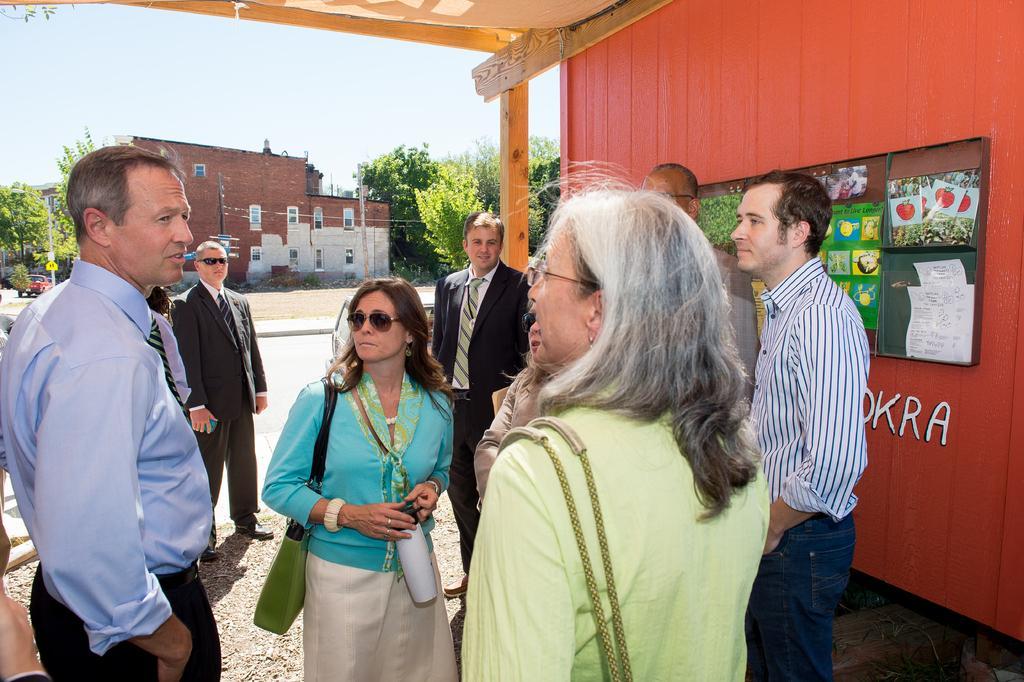In one or two sentences, can you explain what this image depicts? In this picture we can see group of people standing on the path. A woman wearing bag and holding a bottle in her hand. We can see a broad on the pole. There is a car, few trees and buildings in the background. We can see some posters and papers on the wooden wall. 